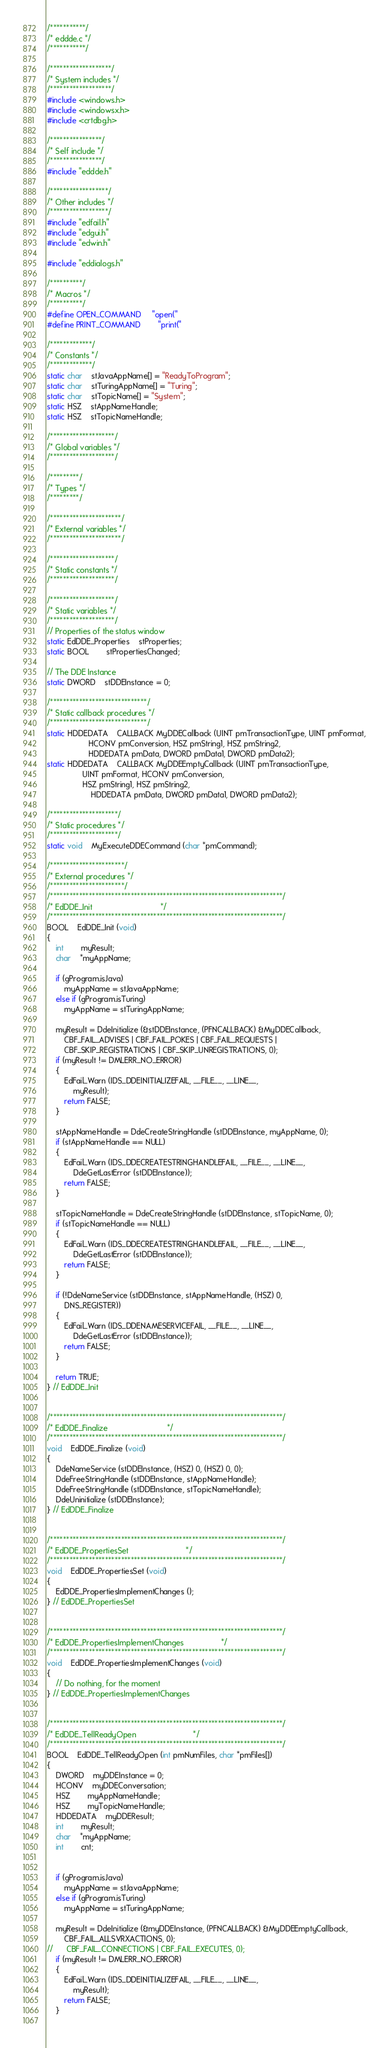Convert code to text. <code><loc_0><loc_0><loc_500><loc_500><_C_>/***********/
/* eddde.c */
/***********/

/*******************/
/* System includes */
/*******************/
#include <windows.h>
#include <windowsx.h>
#include <crtdbg.h>

/****************/
/* Self include */
/****************/
#include "eddde.h"

/******************/
/* Other includes */
/******************/
#include "edfail.h"
#include "edgui.h"
#include "edwin.h"

#include "eddialogs.h"

/**********/
/* Macros */
/**********/
#define OPEN_COMMAND		"open("
#define PRINT_COMMAND		"print("

/*************/
/* Constants */
/*************/
static char	stJavaAppName[] = "ReadyToProgram";
static char	stTuringAppName[] = "Turing";
static char	stTopicName[] = "System";
static HSZ	stAppNameHandle;
static HSZ	stTopicNameHandle;

/********************/
/* Global variables */
/********************/

/*********/
/* Types */
/*********/

/**********************/
/* External variables */
/**********************/

/********************/
/* Static constants */
/********************/

/********************/
/* Static variables */
/********************/
// Properties of the status window
static EdDDE_Properties	stProperties;
static BOOL		stPropertiesChanged;

// The DDE Instance
static DWORD	stDDEInstance = 0;

/******************************/
/* Static callback procedures */
/******************************/
static HDDEDATA	CALLBACK MyDDECallback (UINT pmTransactionType, UINT pmFormat, 
			       HCONV pmConversion, HSZ pmString1, HSZ pmString2,
			       HDDEDATA pmData, DWORD pmData1, DWORD pmData2);
static HDDEDATA	CALLBACK MyDDEEmptyCallback (UINT pmTransactionType, 
				UINT pmFormat, HCONV pmConversion, 
				HSZ pmString1, HSZ pmString2,
			        HDDEDATA pmData, DWORD pmData1, DWORD pmData2);

/*********************/
/* Static procedures */
/*********************/
static void	MyExecuteDDECommand (char *pmCommand);

/***********************/
/* External procedures */
/***********************/
/************************************************************************/
/* EdDDE_Init								*/
/************************************************************************/
BOOL	EdDDE_Init (void)
{
    int		myResult;
    char	*myAppName;
    
    if (gProgram.isJava)
        myAppName = stJavaAppName;
    else if (gProgram.isTuring)
        myAppName = stTuringAppName;
        
    myResult = DdeInitialize (&stDDEInstance, (PFNCALLBACK) &MyDDECallback,
    	CBF_FAIL_ADVISES | CBF_FAIL_POKES | CBF_FAIL_REQUESTS | 
    	CBF_SKIP_REGISTRATIONS | CBF_SKIP_UNREGISTRATIONS, 0);
    if (myResult != DMLERR_NO_ERROR)
    {
    	EdFail_Warn (IDS_DDEINITIALIZEFAIL, __FILE__, __LINE__,
    	    myResult);
        return FALSE;
    }
    
    stAppNameHandle = DdeCreateStringHandle (stDDEInstance, myAppName, 0);
    if (stAppNameHandle == NULL)
    {
    	EdFail_Warn (IDS_DDECREATESTRINGHANDLEFAIL, __FILE__, __LINE__,
    	    DdeGetLastError (stDDEInstance));
        return FALSE;
    }

    stTopicNameHandle = DdeCreateStringHandle (stDDEInstance, stTopicName, 0);
    if (stTopicNameHandle == NULL)
    {
    	EdFail_Warn (IDS_DDECREATESTRINGHANDLEFAIL, __FILE__, __LINE__,
    	    DdeGetLastError (stDDEInstance));
        return FALSE;
    }

    if (!DdeNameService (stDDEInstance, stAppNameHandle, (HSZ) 0, 
        DNS_REGISTER))
    {
    	EdFail_Warn (IDS_DDENAMESERVICEFAIL, __FILE__, __LINE__,
    	    DdeGetLastError (stDDEInstance));
        return FALSE;
    }
    
    return TRUE;
} // EdDDE_Init


/************************************************************************/
/* EdDDE_Finalize							*/
/************************************************************************/
void	EdDDE_Finalize (void)
{
    DdeNameService (stDDEInstance, (HSZ) 0, (HSZ) 0, 0);
    DdeFreeStringHandle (stDDEInstance, stAppNameHandle);
    DdeFreeStringHandle (stDDEInstance, stTopicNameHandle);
    DdeUninitialize (stDDEInstance);
} // EdDDE_Finalize


/************************************************************************/
/* EdDDE_PropertiesSet							*/
/************************************************************************/
void	EdDDE_PropertiesSet (void)
{
    EdDDE_PropertiesImplementChanges ();
} // EdDDE_PropertiesSet

	
/************************************************************************/
/* EdDDE_PropertiesImplementChanges					*/
/************************************************************************/
void	EdDDE_PropertiesImplementChanges (void)
{
    // Do nothing, for the moment	
} // EdDDE_PropertiesImplementChanges


/************************************************************************/
/* EdDDE_TellReadyOpen							*/
/************************************************************************/
BOOL	EdDDE_TellReadyOpen (int pmNumFiles, char *pmFiles[])
{
    DWORD	myDDEInstance = 0;
    HCONV	myDDEConversation;
    HSZ		myAppNameHandle;
    HSZ		myTopicNameHandle;
    HDDEDATA	myDDEResult;
    int		myResult;
    char	*myAppName;
    int		cnt;
    
    
    if (gProgram.isJava)
        myAppName = stJavaAppName;
    else if (gProgram.isTuring)
        myAppName = stTuringAppName;

    myResult = DdeInitialize (&myDDEInstance, (PFNCALLBACK) &MyDDEEmptyCallback,
    	CBF_FAIL_ALLSVRXACTIONS, 0);
//    	CBF_FAIL_CONNECTIONS | CBF_FAIL_EXECUTES, 0);
    if (myResult != DMLERR_NO_ERROR)
    {
    	EdFail_Warn (IDS_DDEINITIALIZEFAIL, __FILE__, __LINE__,
    	    myResult);
        return FALSE;
    }
    </code> 